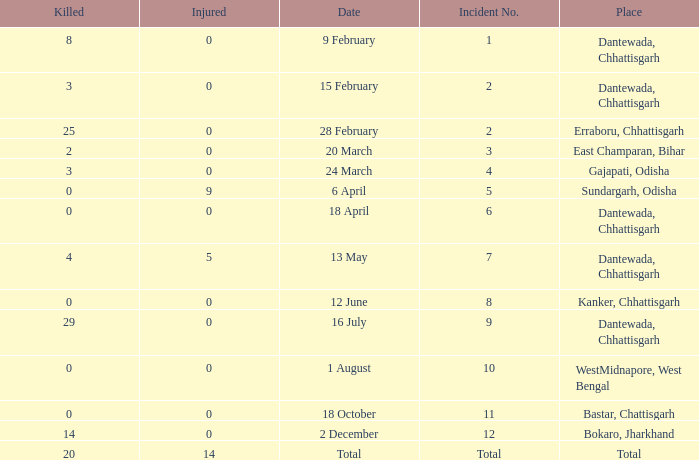How many people were injured in total in East Champaran, Bihar with more than 2 people killed? 0.0. 